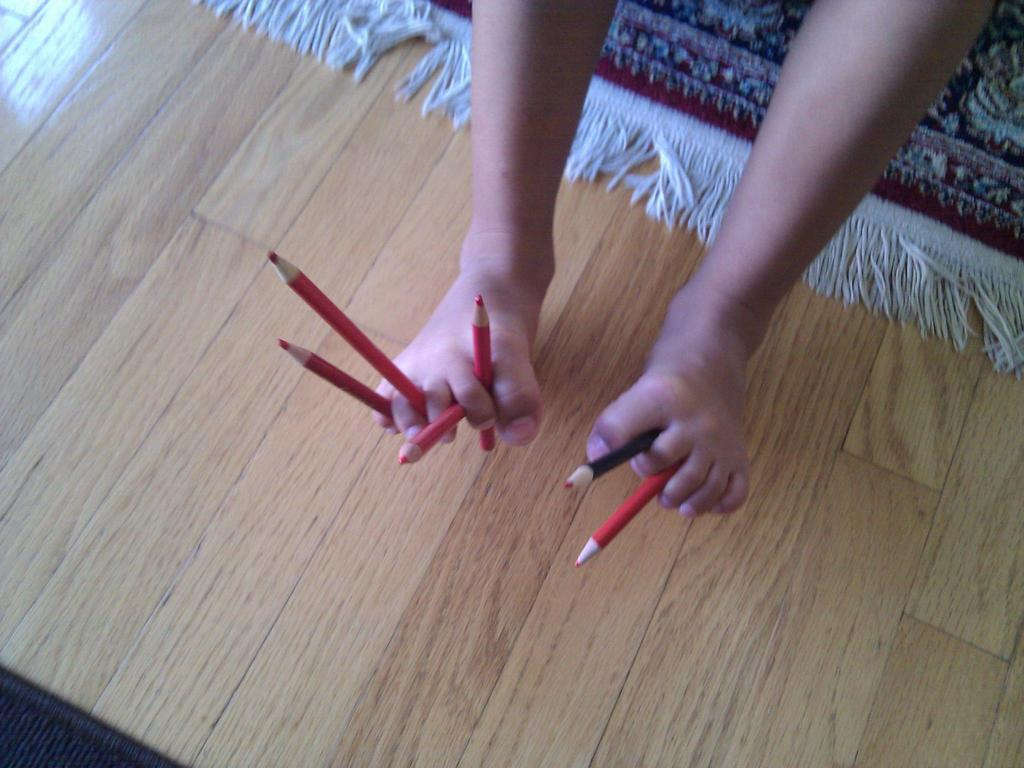Who or what is the main subject in the image? There is a person in the image. What is the person holding in the image? The person is holding pencils with legs. What color is the carpet in the background? The carpet in the background is maroon-colored. What type of surface is the carpet placed on? The carpet is on a wooden board. What type of powder is being used by the doctor in the image? There is no doctor or powder present in the image. What belief system is the person in the image following? The image does not provide any information about the person's belief system. 